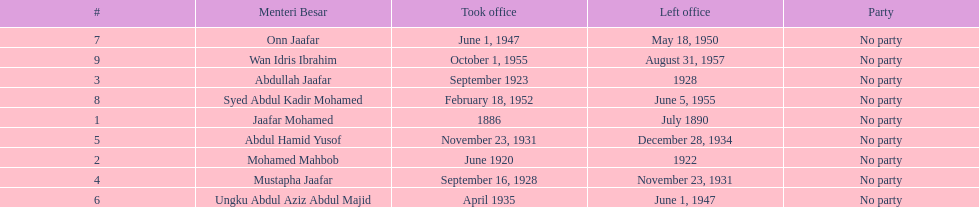Who spend the most amount of time in office? Ungku Abdul Aziz Abdul Majid. 